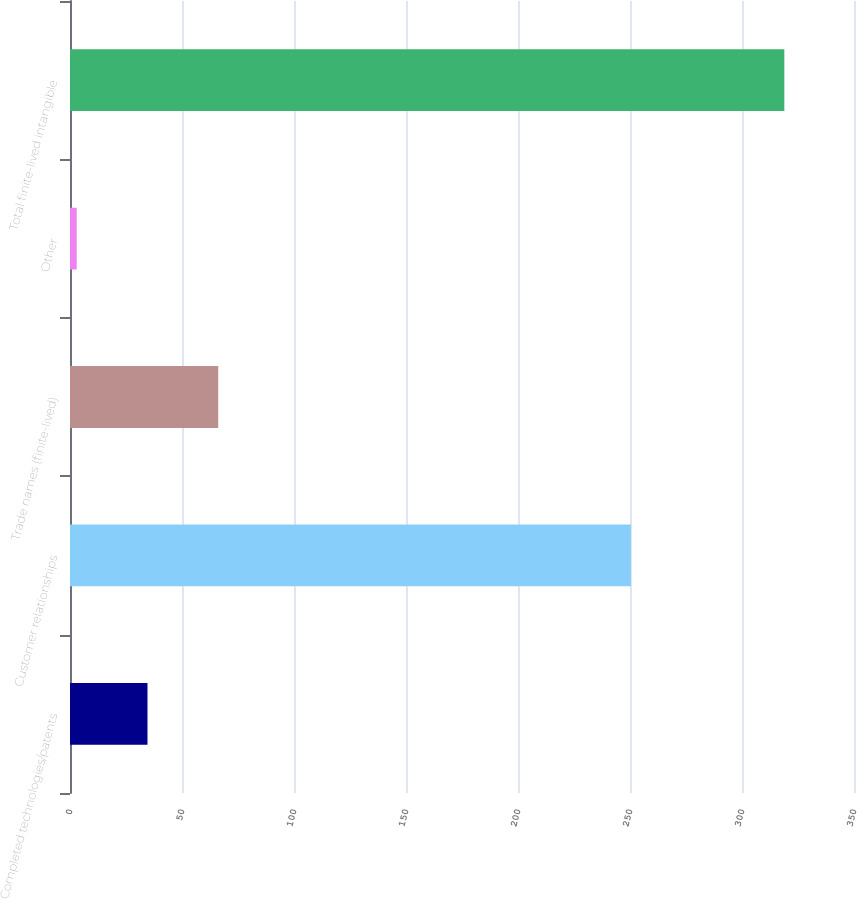Convert chart to OTSL. <chart><loc_0><loc_0><loc_500><loc_500><bar_chart><fcel>Completed technologies/patents<fcel>Customer relationships<fcel>Trade names (finite-lived)<fcel>Other<fcel>Total finite-lived intangible<nl><fcel>34.59<fcel>250.4<fcel>66.18<fcel>3<fcel>318.9<nl></chart> 